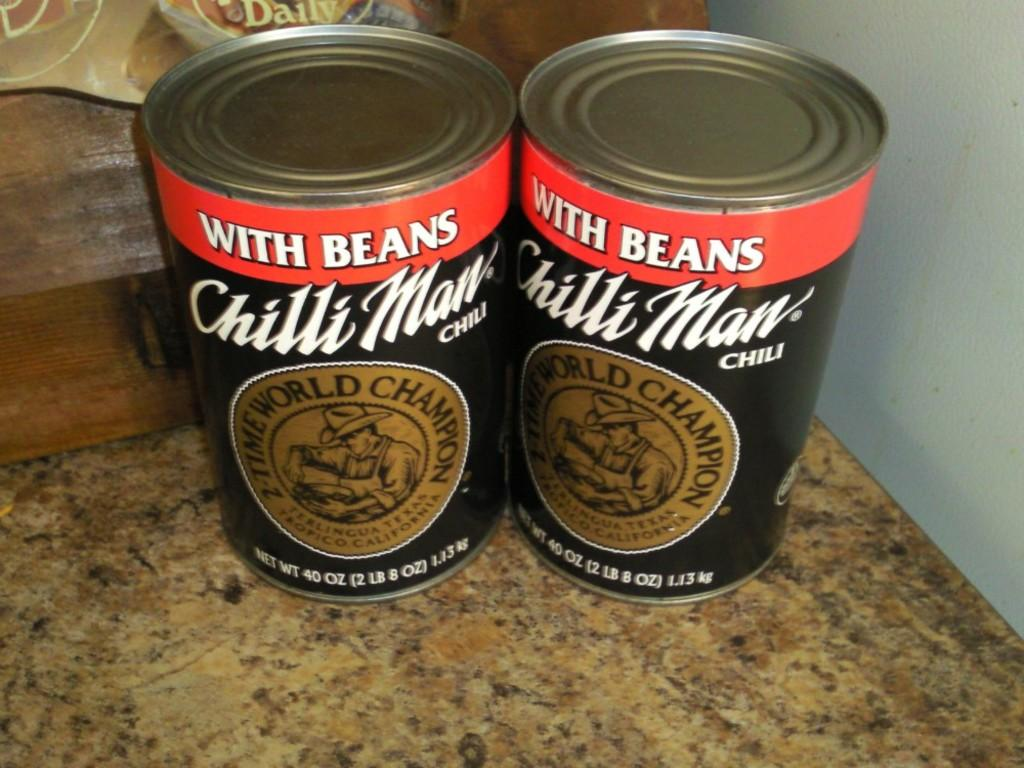<image>
Write a terse but informative summary of the picture. Two cans of chili with beans made by Chili Man, a two time world champion company, are sitting on a surface. 